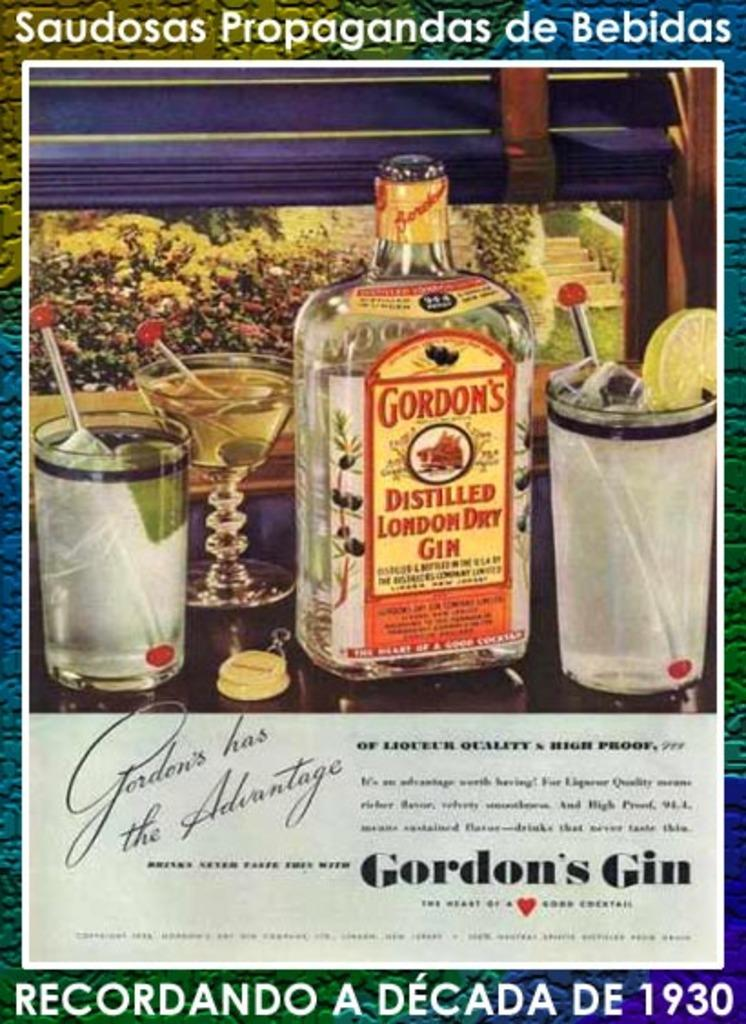Provide a one-sentence caption for the provided image. A colorful ad for Gordon's Gin displaying several glasses. 